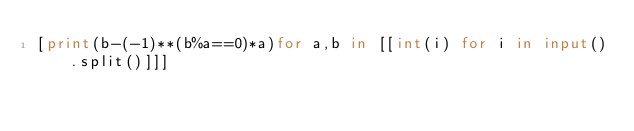<code> <loc_0><loc_0><loc_500><loc_500><_Python_>[print(b-(-1)**(b%a==0)*a)for a,b in [[int(i) for i in input().split()]]]</code> 